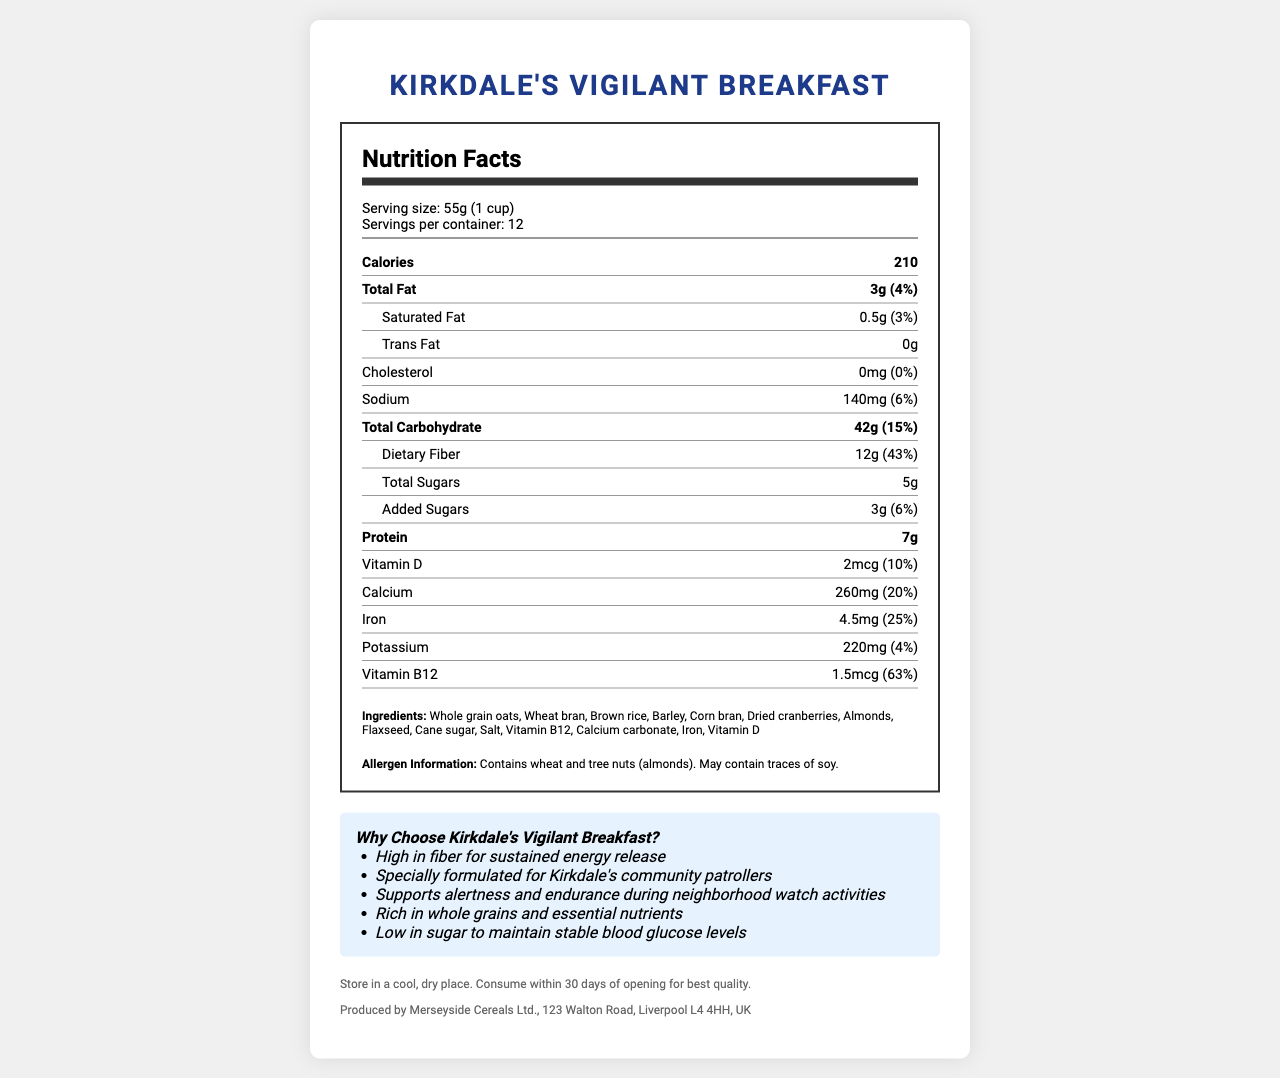what is the name of the cereal? The name of the cereal is clearly mentioned at the top of the document.
Answer: Kirkdale's Vigilant Breakfast how many servings are in one container? Under the serving information, it states there are 12 servings per container.
Answer: 12 what is the amount of dietary fiber per serving? The dietary fiber amounts to 12g per serving as indicated in the nutrient section.
Answer: 12g how much calcium does one serving contain? The calcium content per serving is clearly mentioned as 260mg.
Answer: 260mg what is the percentage of the daily value for Vitamin D? Under the nutrient details, it is stated that Vitamin D provides 10% of the daily value per serving.
Answer: 10% what allergen information is provided? A. Contains wheat B. Contains tree nuts C. Contains soy D. All of the above The allergen information states it contains wheat, tree nuts (almonds), and may contain traces of soy.
Answer: D. All of the above which vitamin has the highest daily value percentage? A. Vitamin D B. Vitamin B12 C. Calcium D. Iron Vitamin B12 provides 63% of the daily value, which is the highest compared to others.
Answer: B: Vitamin B12 is the product high in fiber? The product contains 12g of dietary fiber per serving, which is 43% of the daily value, indicating that it is high in fiber.
Answer: Yes is there any cholesterol in this product? The document states that the cholesterol content is 0mg, which means there is no cholesterol.
Answer: No summarize the main idea of the document. The document is a nutrition facts label for a high-fiber cereal called Kirkdale's Vigilant Breakfast, designed to support sustained energy, alertness, and endurance. It outlines the serving size, number of servings, calorie count, detailed nutritional content, ingredients, allergen information, marketing claims, storage instructions, and manufacturer information.
Answer: The document provides detailed nutritional information about Kirkdale's Vigilant Breakfast cereal, emphasizing its health benefits such as high fiber for sustained energy release, low sugar content, and inclusion of essential nutrients. Additionally, it highlights its suitability for community patrollers in Kirkdale. what is the address of the manufacturer? The manufacturer's address is given in the footer of the document.
Answer: 123 Walton Road, Liverpool L4 4HH, UK how much protein does one serving of the cereal contain? According to the nutrition facts, one serving contains 7g of protein.
Answer: 7g what are the main ingredients in this cereal? The ingredient list included in the document provides this information.
Answer: Whole grain oats, wheat bran, brown rice, barley, corn bran, dried cranberries, almonds, flaxseed, cane sugar, salt, Vitamin B12, calcium carbonate, iron, Vitamin D what are the marketing claims highlighted in the document? Under the "Why Choose Kirkdale's Vigilant Breakfast?" section, the document lists these marketing claims.
Answer: High in fiber for sustained energy release, specially formulated for Kirkdale's community patrollers, supports alertness and endurance during neighborhood watch activities, rich in whole grains and essential nutrients, low in sugar to maintain stable blood glucose levels who is the CEO of the manufacturer company? The document does not provide any information about the CEO of Merseyside Cereals Ltd.
Answer: Not enough information 